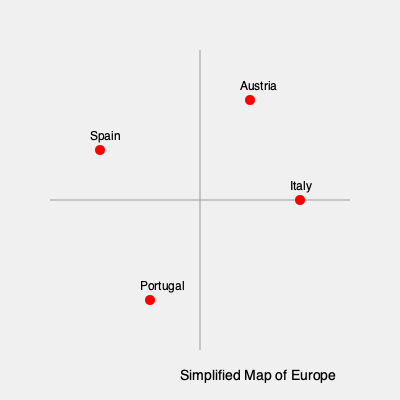Based on the simplified map of Europe showing some Alps Tour tournament locations, which country appears to host the most northerly tournament? To determine the most northerly tournament location, we need to analyze the positions of the marked countries on the map:

1. The map shows four countries: Spain, Austria, Italy, and Portugal.
2. In a typical map of Europe, north is at the top of the map.
3. Looking at the vertical positions of the marked locations:
   - Spain is roughly in the middle vertically
   - Portugal is near the bottom of the map
   - Italy is also roughly in the middle vertically
   - Austria is the highest point on the map

4. The higher a point is on the map, the more northerly it is in Europe.
5. Therefore, the most northerly tournament location among these countries is in Austria.
Answer: Austria 